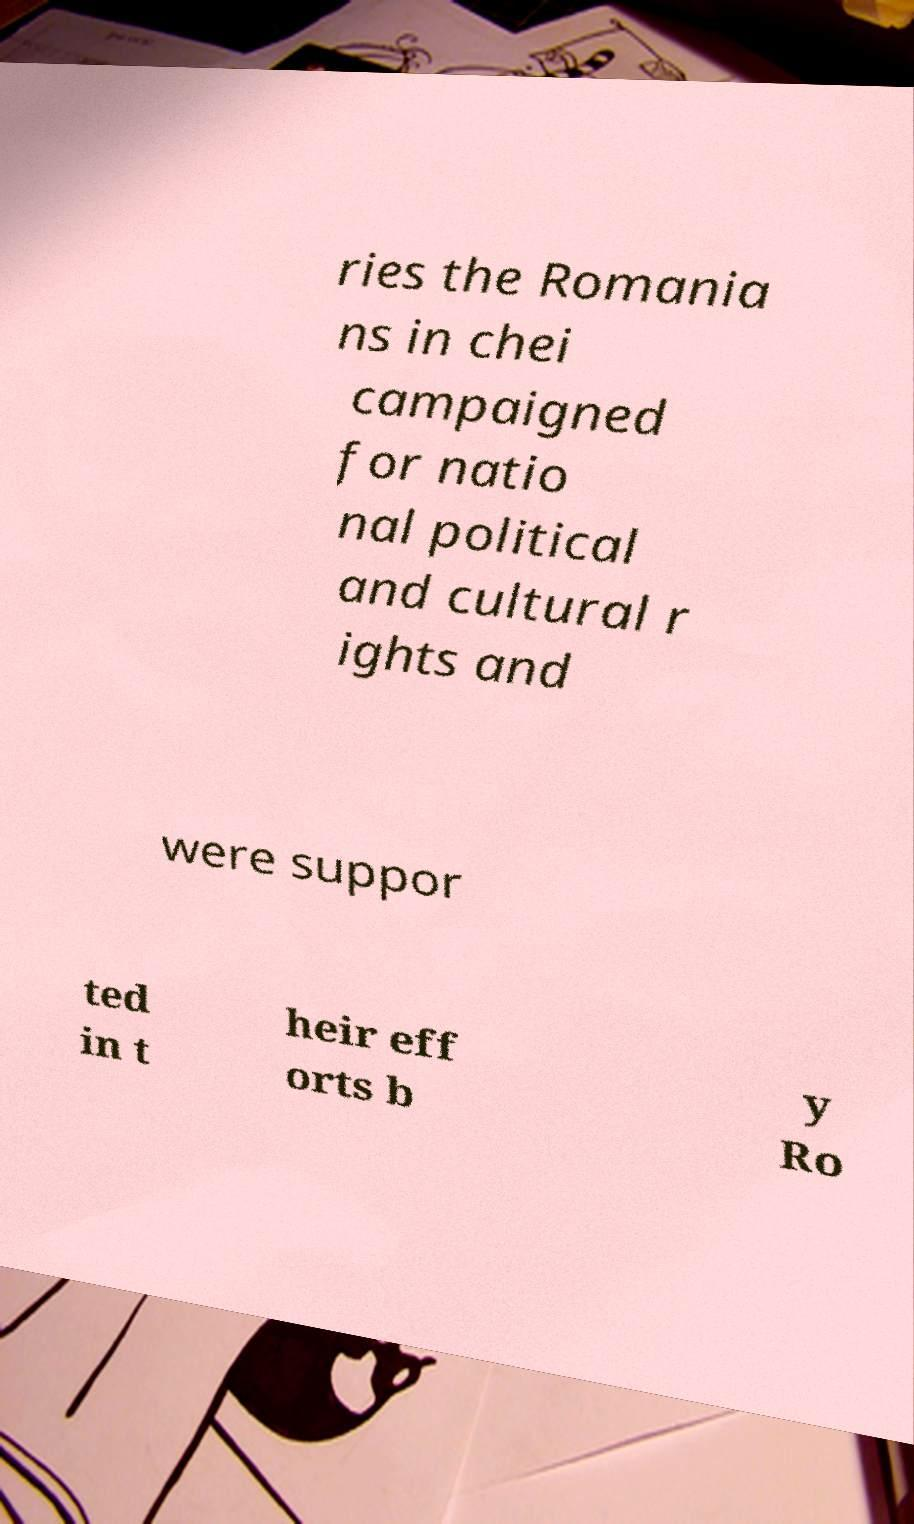Can you read and provide the text displayed in the image?This photo seems to have some interesting text. Can you extract and type it out for me? ries the Romania ns in chei campaigned for natio nal political and cultural r ights and were suppor ted in t heir eff orts b y Ro 